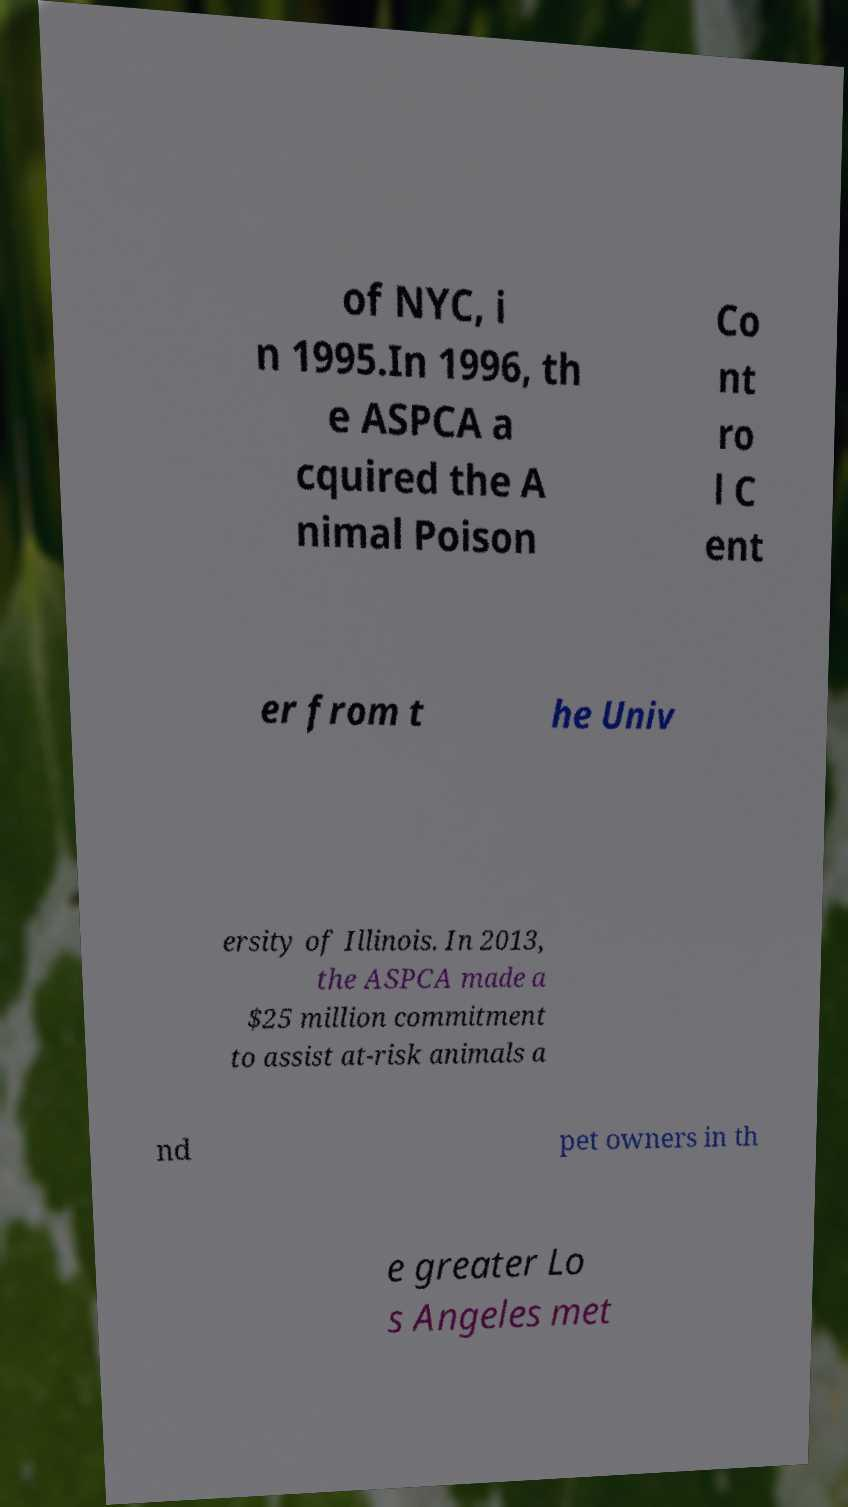For documentation purposes, I need the text within this image transcribed. Could you provide that? of NYC, i n 1995.In 1996, th e ASPCA a cquired the A nimal Poison Co nt ro l C ent er from t he Univ ersity of Illinois. In 2013, the ASPCA made a $25 million commitment to assist at-risk animals a nd pet owners in th e greater Lo s Angeles met 